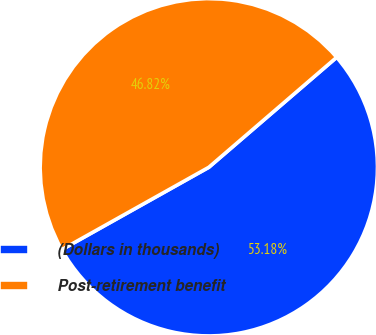<chart> <loc_0><loc_0><loc_500><loc_500><pie_chart><fcel>(Dollars in thousands)<fcel>Post-retirement benefit<nl><fcel>53.18%<fcel>46.82%<nl></chart> 